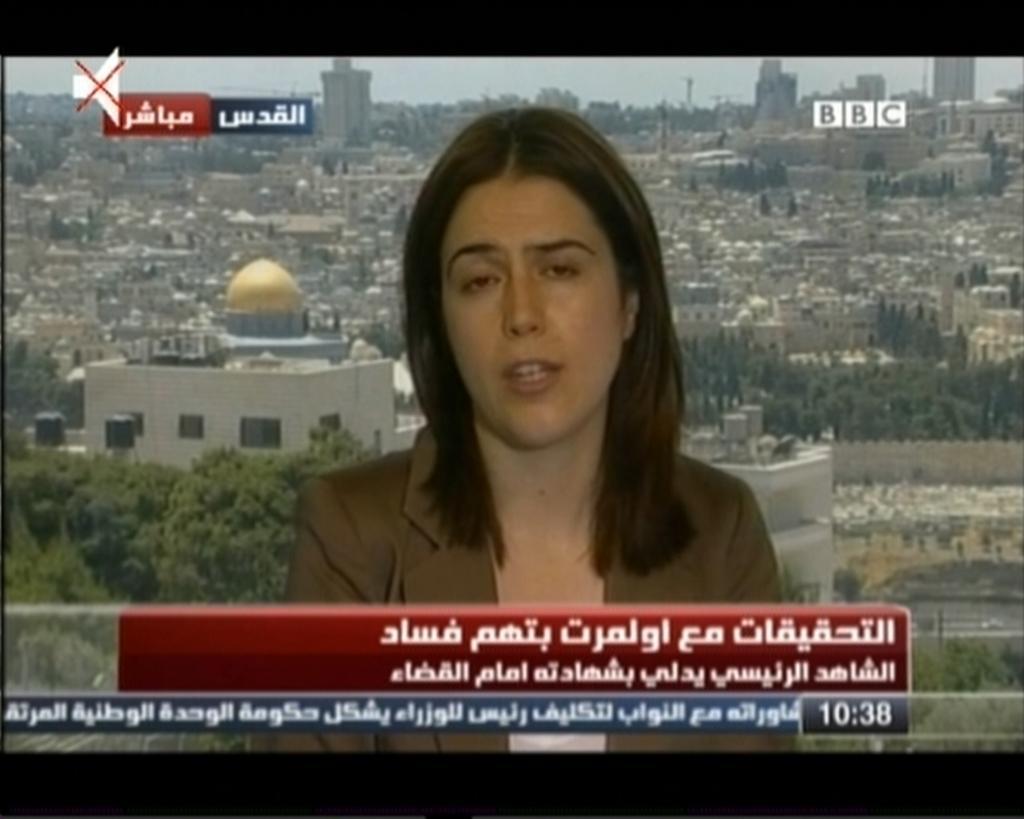Please provide a concise description of this image. In this picture we can see a screen, in this screen we can see a woman is speaking, there is some text at the bottom, in the background we can see buildings, trees and the sky, there is an icon at the left top of the picture. 